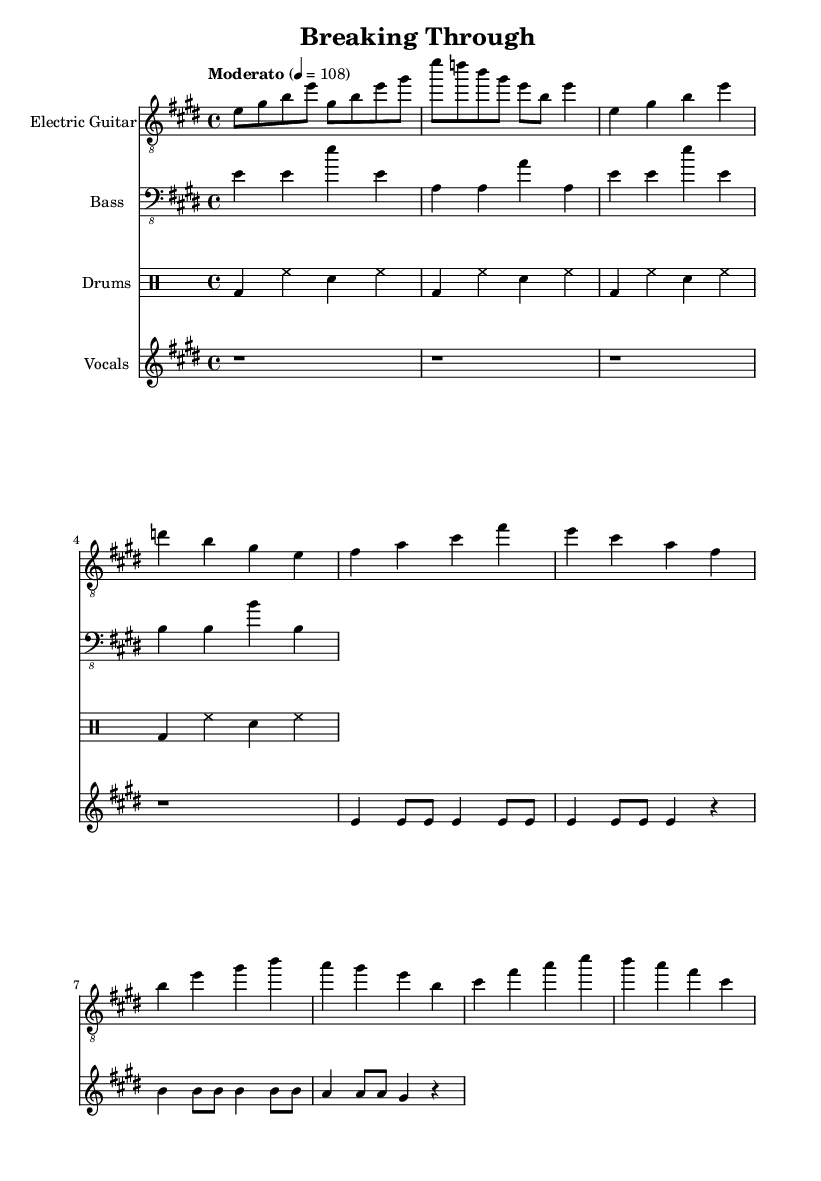What is the key signature of this music? The key signature is E major, which has four sharps (F#, C#, G#, D#).
Answer: E major What is the time signature of this music? The time signature is 4/4, indicating four beats per measure.
Answer: 4/4 What is the tempo marking of the piece? The tempo marking indicates "Moderato" with a metronome speed of 108 beats per minute.
Answer: Moderato, 108 How many measures are there in the intro section? The intro section consists of 2 measures, as indicated by the series of notes before the verse begins.
Answer: 2 What is the first lyric of the verse? The first lyric of the verse is "Star". This can be found at the beginning of the lyric section.
Answer: Star Identify the main theme expressed in the chorus lyrics. The main theme in the chorus lyrics is about "breaking through barriers", as indicated by the repeated phrase in the lyrics.
Answer: Breaking through barriers How does the bass pattern relate to the chord progression? The bass pattern mostly follows the root notes of the chords played in the electric guitar part, providing a foundational harmonic support for the progressions.
Answer: Root notes 